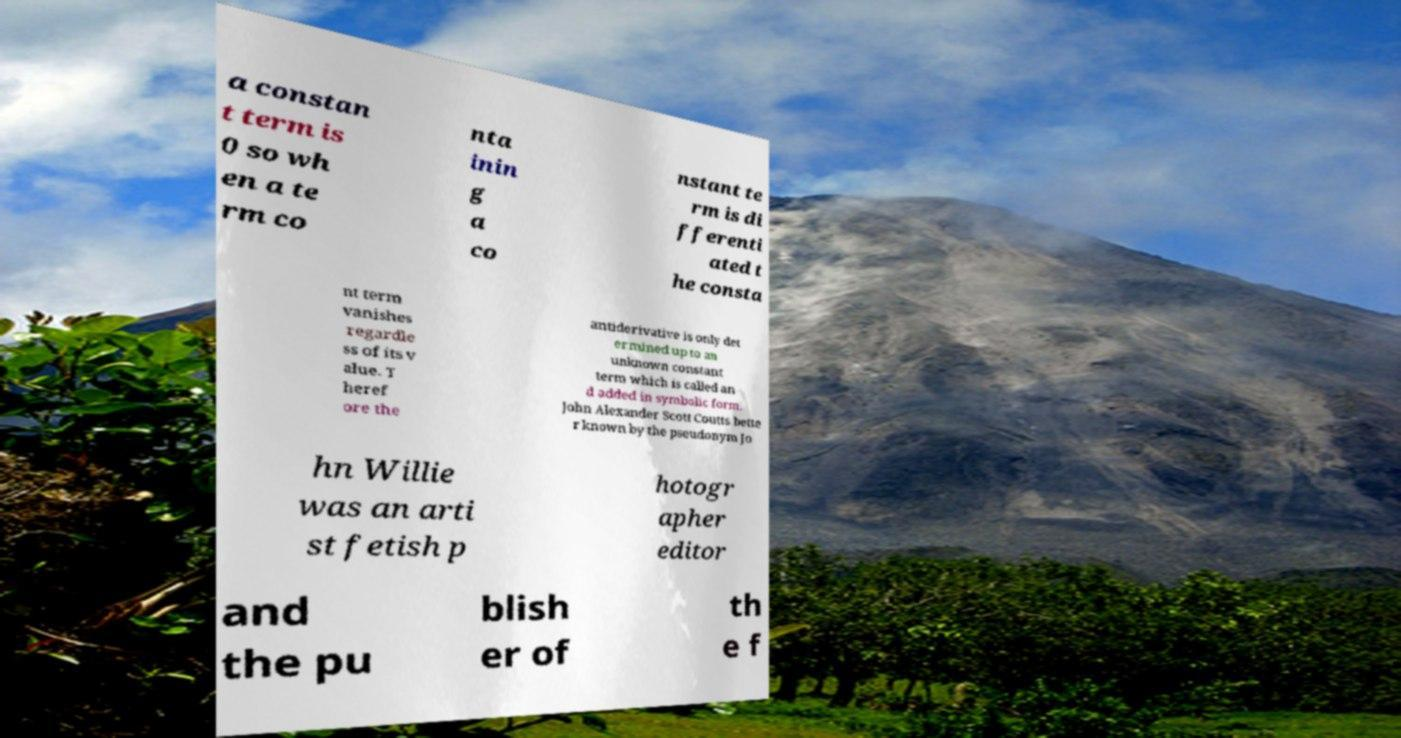Please identify and transcribe the text found in this image. a constan t term is 0 so wh en a te rm co nta inin g a co nstant te rm is di fferenti ated t he consta nt term vanishes regardle ss of its v alue. T heref ore the antiderivative is only det ermined up to an unknown constant term which is called an d added in symbolic form. John Alexander Scott Coutts bette r known by the pseudonym Jo hn Willie was an arti st fetish p hotogr apher editor and the pu blish er of th e f 